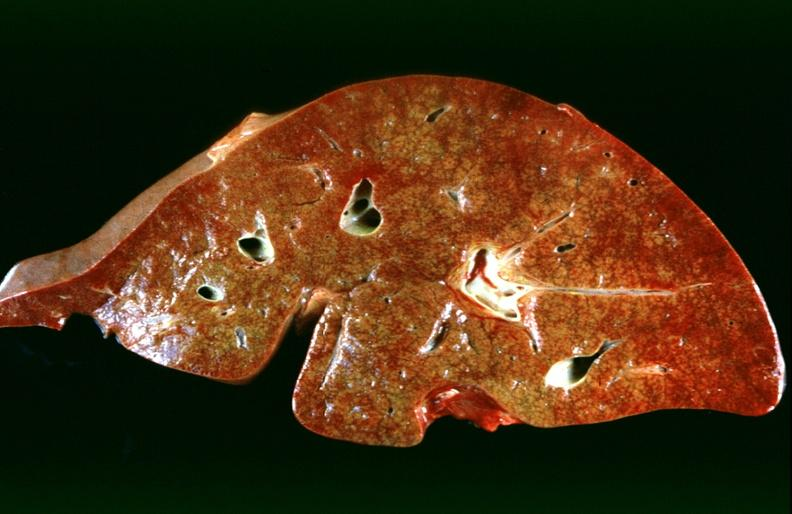s krukenberg tumor present?
Answer the question using a single word or phrase. No 